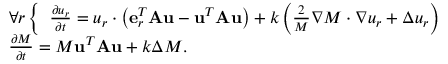Convert formula to latex. <formula><loc_0><loc_0><loc_500><loc_500>\begin{array} { r l } & { \forall r \left \{ \begin{array} { r } { \frac { \partial u _ { r } } { \partial t } = u _ { r } \cdot \left ( e _ { r } ^ { T } A u - u ^ { T } A u \right ) + k \left ( \frac { 2 } { M } \nabla M \cdot \nabla u _ { r } + \Delta u _ { r } \right ) } \end{array} } \\ & { \frac { \partial M } { \partial t } = M u ^ { T } A u + k \Delta M . } \end{array}</formula> 